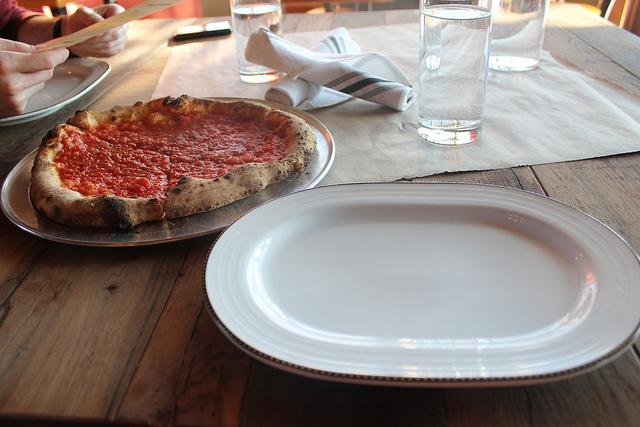Why is the plate empty? unused 